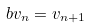Convert formula to latex. <formula><loc_0><loc_0><loc_500><loc_500>b v _ { n } = v _ { n + 1 }</formula> 